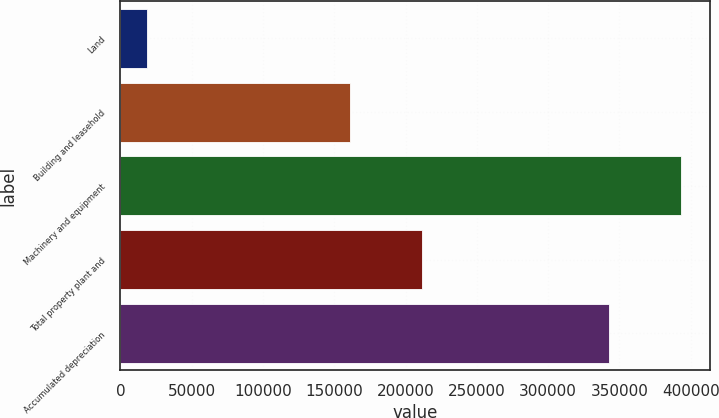Convert chart. <chart><loc_0><loc_0><loc_500><loc_500><bar_chart><fcel>Land<fcel>Building and leasehold<fcel>Machinery and equipment<fcel>Total property plant and<fcel>Accumulated depreciation<nl><fcel>18780<fcel>160697<fcel>393573<fcel>211332<fcel>342938<nl></chart> 